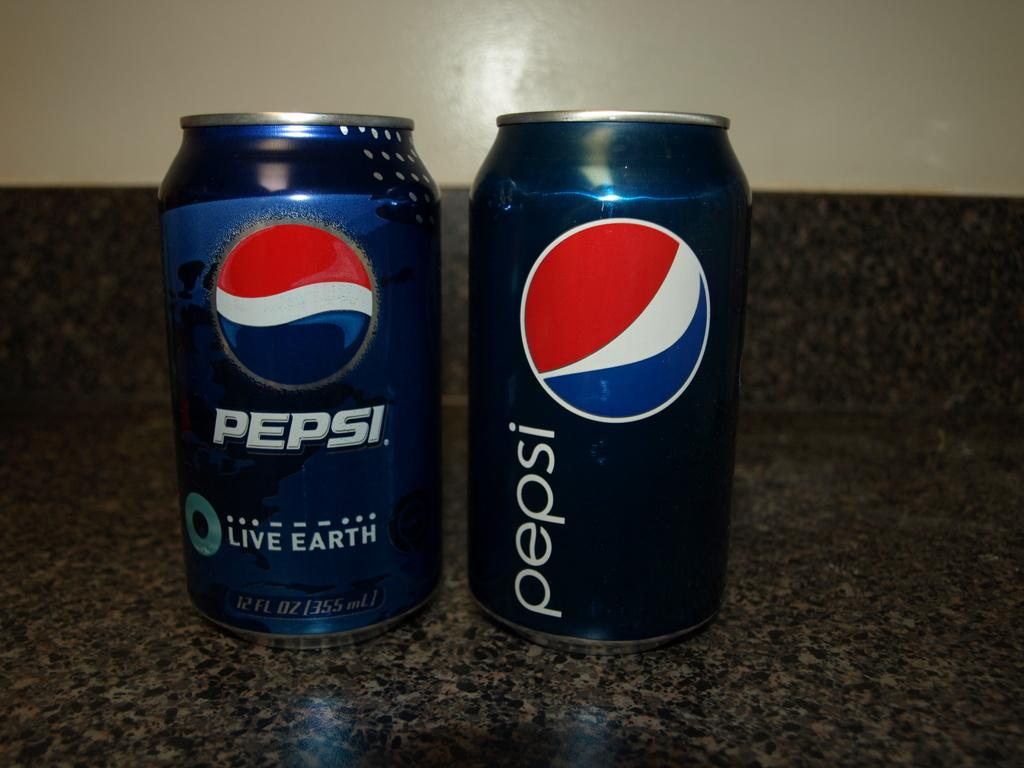<image>
Offer a succinct explanation of the picture presented. Two tins of Pepsi sit side by side on a worktop. 